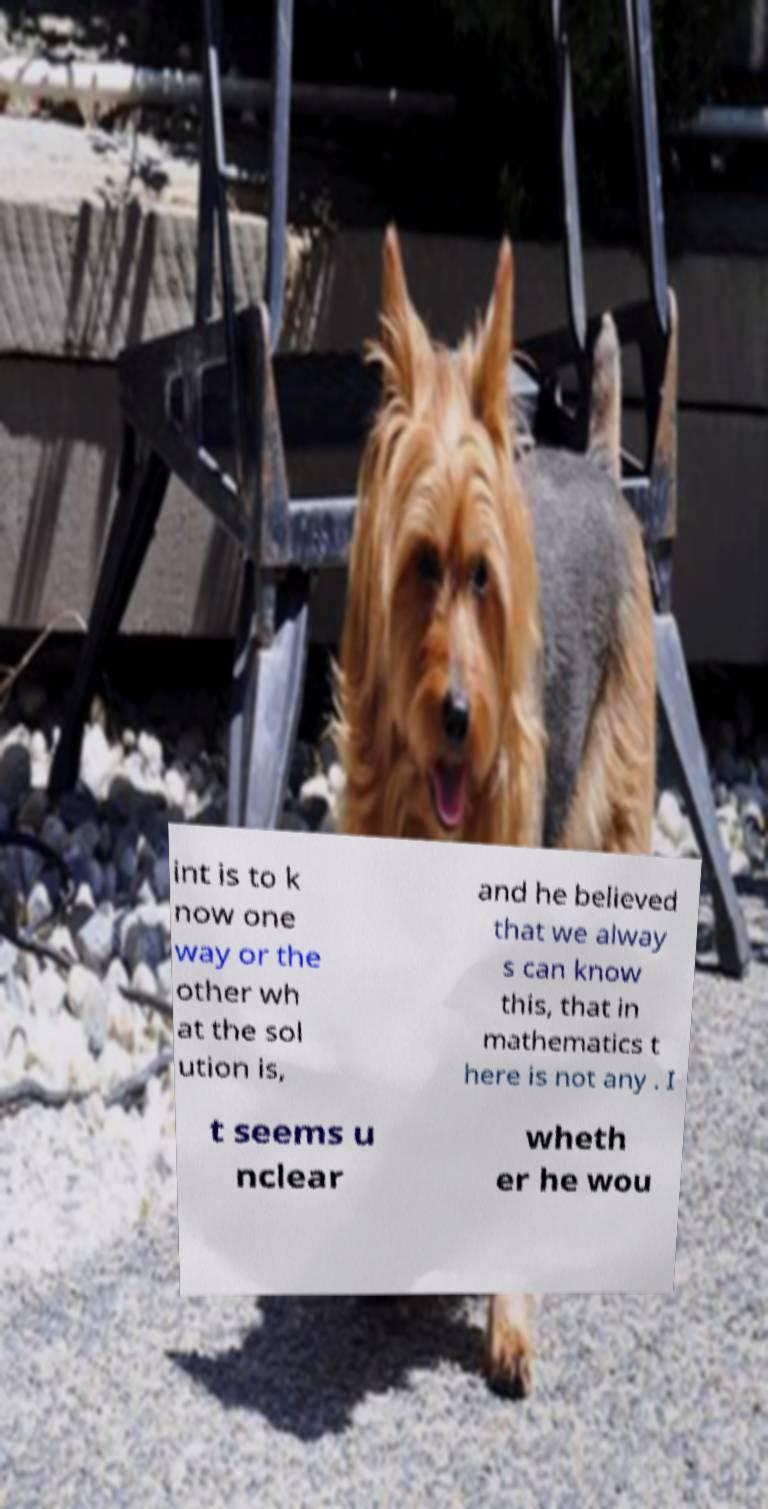What messages or text are displayed in this image? I need them in a readable, typed format. int is to k now one way or the other wh at the sol ution is, and he believed that we alway s can know this, that in mathematics t here is not any . I t seems u nclear wheth er he wou 